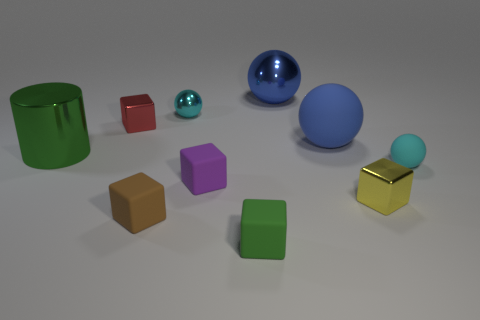What number of other objects are the same color as the big cylinder?
Give a very brief answer. 1. What shape is the blue shiny object?
Offer a terse response. Sphere. What color is the sphere on the left side of the tiny block in front of the small brown rubber object?
Ensure brevity in your answer.  Cyan. There is a shiny cylinder; is it the same color as the big metal object that is to the right of the small red metal block?
Your answer should be very brief. No. There is a small thing that is both in front of the small purple rubber cube and on the right side of the blue rubber object; what material is it?
Give a very brief answer. Metal. Is there a brown shiny sphere of the same size as the brown block?
Ensure brevity in your answer.  No. There is a yellow block that is the same size as the red object; what is its material?
Provide a succinct answer. Metal. There is a brown thing; what number of small purple things are to the left of it?
Keep it short and to the point. 0. There is a green thing that is behind the green matte thing; is its shape the same as the tiny red shiny object?
Ensure brevity in your answer.  No. Are there any small cyan objects that have the same shape as the large green thing?
Ensure brevity in your answer.  No. 